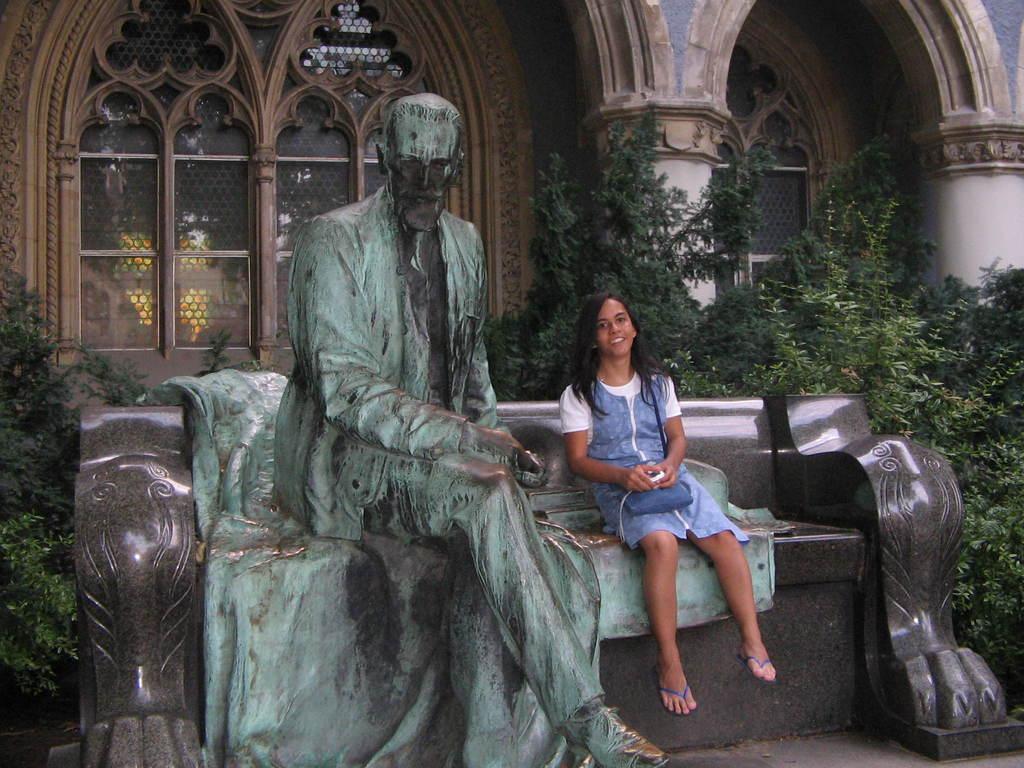In one or two sentences, can you explain what this image depicts? In this picture I can see a girl sitting beside the sculpture on the bench, side I can see some trees, behind there is a building. 